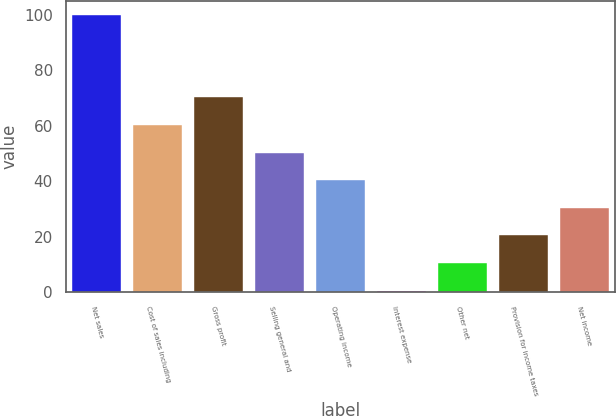Convert chart. <chart><loc_0><loc_0><loc_500><loc_500><bar_chart><fcel>Net sales<fcel>Cost of sales including<fcel>Gross profit<fcel>Selling general and<fcel>Operating income<fcel>Interest expense<fcel>Other net<fcel>Provision for income taxes<fcel>Net income<nl><fcel>100<fcel>60.24<fcel>70.18<fcel>50.3<fcel>40.36<fcel>0.6<fcel>10.54<fcel>20.48<fcel>30.42<nl></chart> 